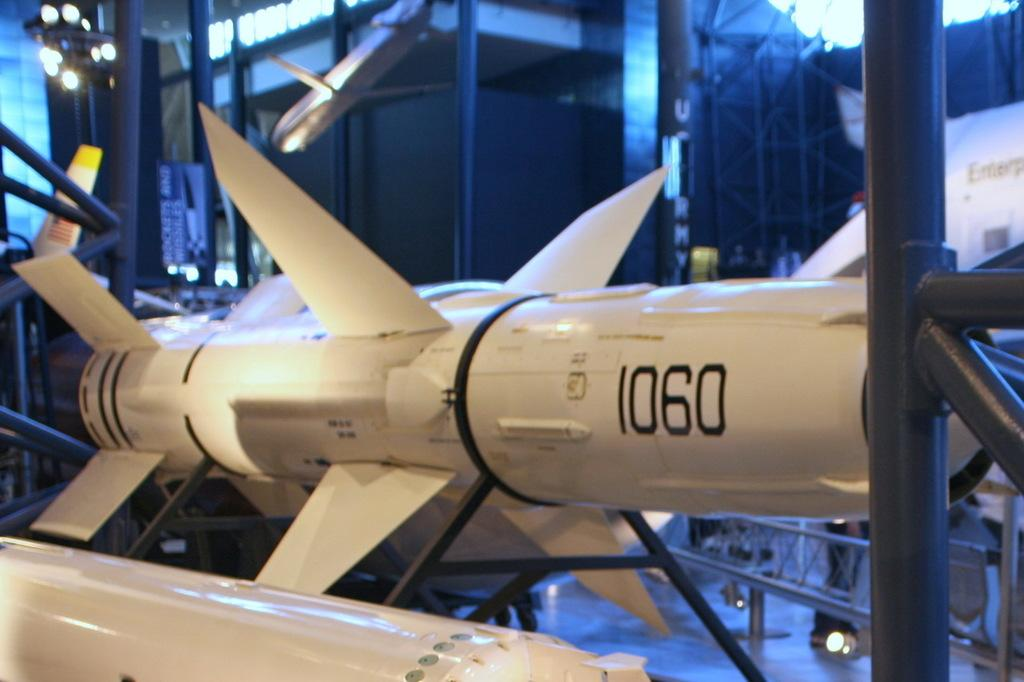What is the main subject of the image? There is a rocket in the image. What can be seen in the background of the image? There are iron poles in the background of the image. What is the taste of the rocket in the image? The rocket in the image is not a food item, so it does not have a taste. How many bees can be seen flying around the rocket in the image? There are no bees present in the image; it only features a rocket and iron poles in the background. 